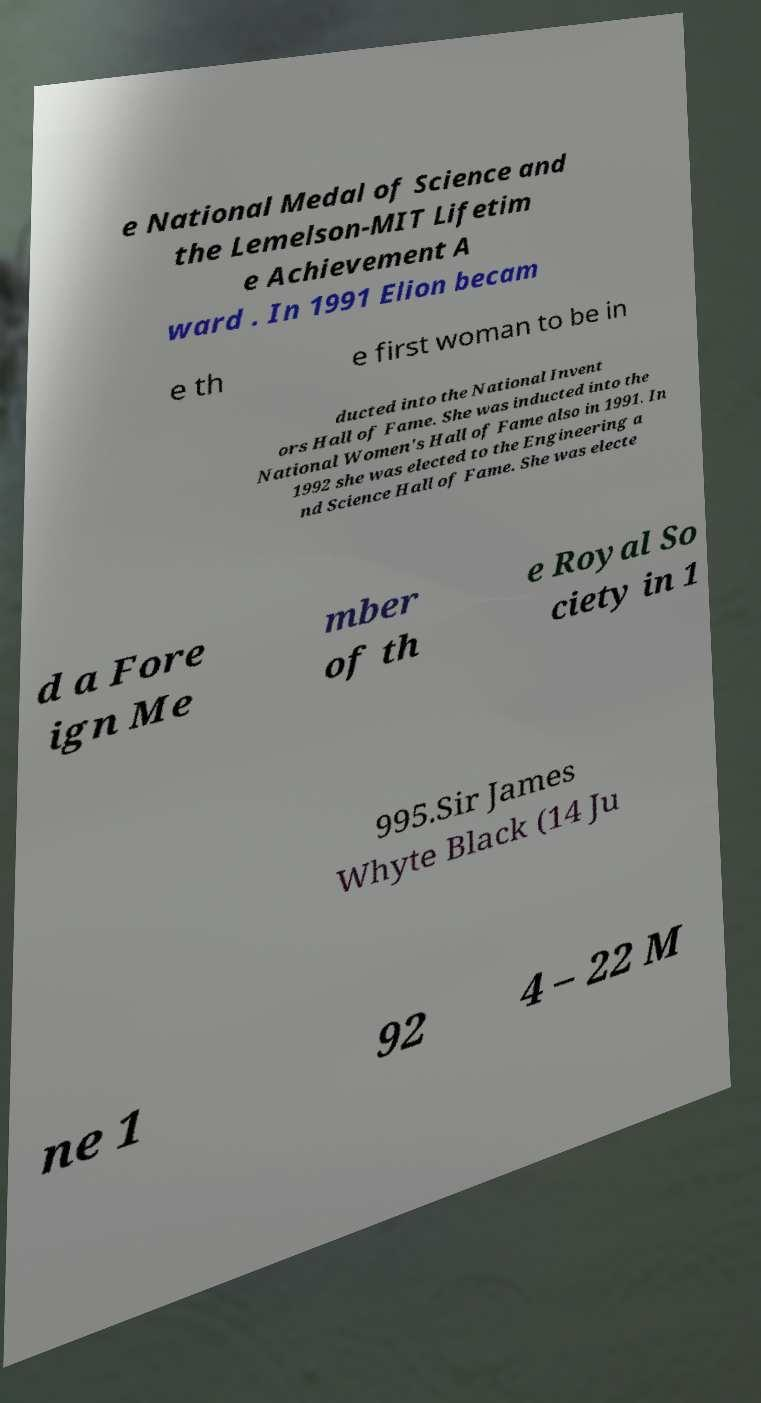There's text embedded in this image that I need extracted. Can you transcribe it verbatim? e National Medal of Science and the Lemelson-MIT Lifetim e Achievement A ward . In 1991 Elion becam e th e first woman to be in ducted into the National Invent ors Hall of Fame. She was inducted into the National Women's Hall of Fame also in 1991. In 1992 she was elected to the Engineering a nd Science Hall of Fame. She was electe d a Fore ign Me mber of th e Royal So ciety in 1 995.Sir James Whyte Black (14 Ju ne 1 92 4 – 22 M 